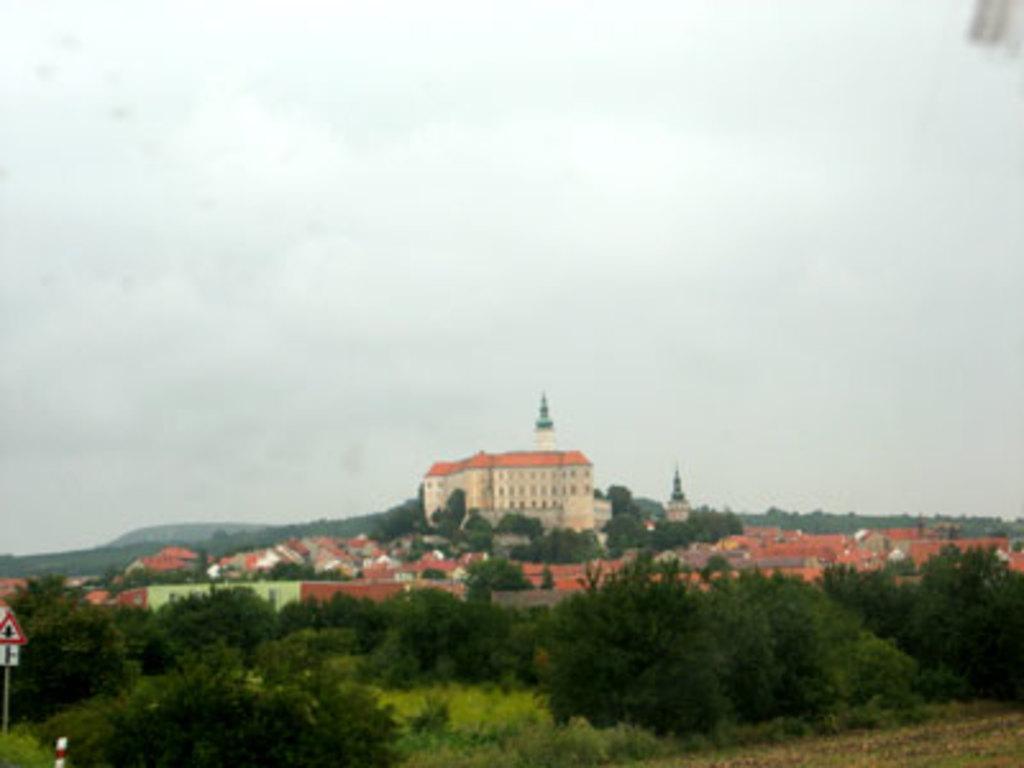Please provide a concise description of this image. This is the picture of a city. In this image there are buildings and trees. At the back there is a mountain. At the top there is sky. At the bottom there is grass. On the left side of the image there are boards on the pole. 